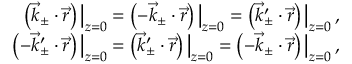<formula> <loc_0><loc_0><loc_500><loc_500>\begin{array} { r } { \left ( \vec { k } _ { \pm } \cdot \vec { r } \right ) \left | _ { z = 0 } = \left ( - \vec { k } _ { \pm } \cdot \vec { r } \right ) \right | _ { z = 0 } = \left ( \vec { k } _ { \pm } ^ { \prime } \cdot \vec { r } \right ) \left | _ { z = 0 } \, , } \\ { \left ( - \vec { k } _ { \pm } ^ { \prime } \cdot \vec { r } \right ) \right | _ { z = 0 } = \left ( \vec { k } _ { \pm } ^ { \prime } \cdot \vec { r } \right ) \left | _ { z = 0 } = \left ( - \vec { k } _ { \pm } \cdot \vec { r } \right ) \right | _ { z = 0 } \, , } \end{array}</formula> 